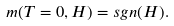<formula> <loc_0><loc_0><loc_500><loc_500>m ( T = 0 , H ) = s g n ( H ) .</formula> 